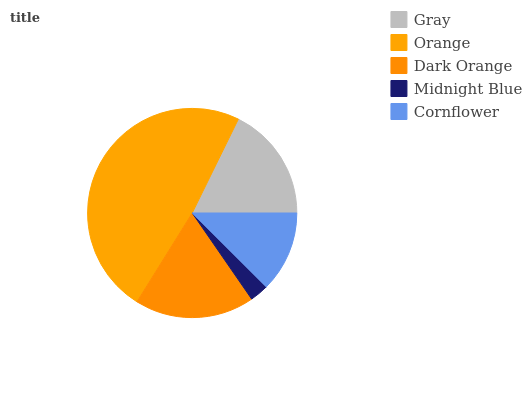Is Midnight Blue the minimum?
Answer yes or no. Yes. Is Orange the maximum?
Answer yes or no. Yes. Is Dark Orange the minimum?
Answer yes or no. No. Is Dark Orange the maximum?
Answer yes or no. No. Is Orange greater than Dark Orange?
Answer yes or no. Yes. Is Dark Orange less than Orange?
Answer yes or no. Yes. Is Dark Orange greater than Orange?
Answer yes or no. No. Is Orange less than Dark Orange?
Answer yes or no. No. Is Gray the high median?
Answer yes or no. Yes. Is Gray the low median?
Answer yes or no. Yes. Is Midnight Blue the high median?
Answer yes or no. No. Is Cornflower the low median?
Answer yes or no. No. 